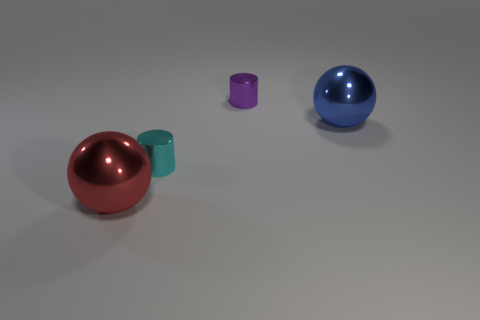Add 4 tiny purple metallic objects. How many objects exist? 8 Subtract 1 blue spheres. How many objects are left? 3 Subtract all green blocks. Subtract all big red spheres. How many objects are left? 3 Add 1 balls. How many balls are left? 3 Add 3 large green metal cylinders. How many large green metal cylinders exist? 3 